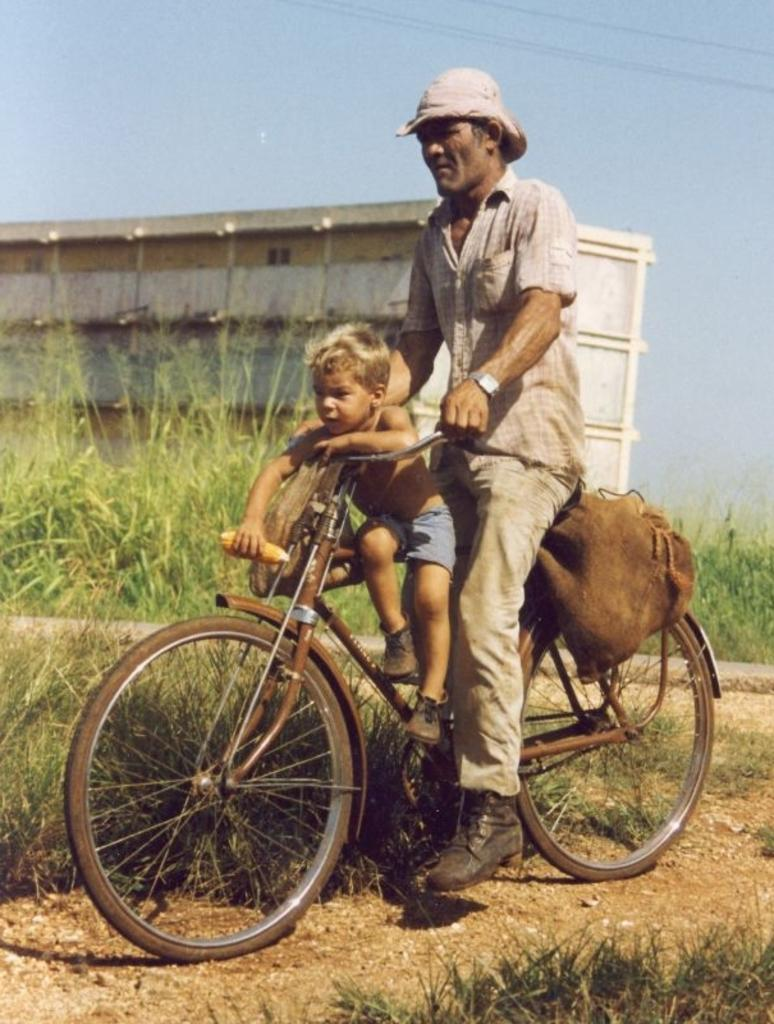What is the man doing in the image? The man is riding a bicycle in the image. Who is with the man on the bicycle? There is a boy sitting on the bicycle with the man. What is the boy holding in his hand? The boy is holding corn in one hand. What can be seen in the background of the image? There are trees, a building, the sky, and wires visible in the background of the image. What type of fear is the boy experiencing while holding the corn? There is no indication in the image that the boy is experiencing any fear, and therefore we cannot determine the type of fear he might be experiencing. 